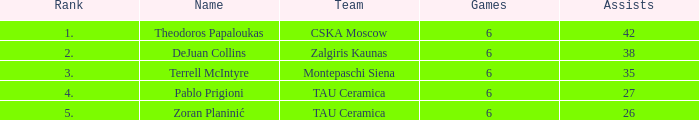What is the smallest number of assists among players ranked 2? 38.0. 